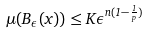<formula> <loc_0><loc_0><loc_500><loc_500>\mu ( B _ { \epsilon } ( x ) ) \leq K \epsilon ^ { n ( 1 - \frac { 1 } { p } ) }</formula> 